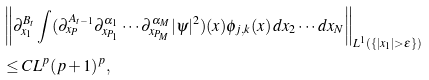Convert formula to latex. <formula><loc_0><loc_0><loc_500><loc_500>& \left \| \partial _ { x _ { 1 } } ^ { B _ { t } } \int ( \partial _ { x _ { P } } ^ { A _ { t - 1 } } \partial _ { x _ { P _ { 1 } } } ^ { \alpha _ { 1 } } \cdots \partial _ { x _ { P _ { M } } } ^ { \alpha _ { M } } | \psi | ^ { 2 } ) ( { x } ) \phi _ { j , k } ( { x } ) \, d x _ { 2 } \cdots d x _ { N } \right \| _ { L ^ { 1 } ( \{ | x _ { 1 } | > \varepsilon \} ) } \\ & \leq C L ^ { p } ( p + 1 ) ^ { p } ,</formula> 